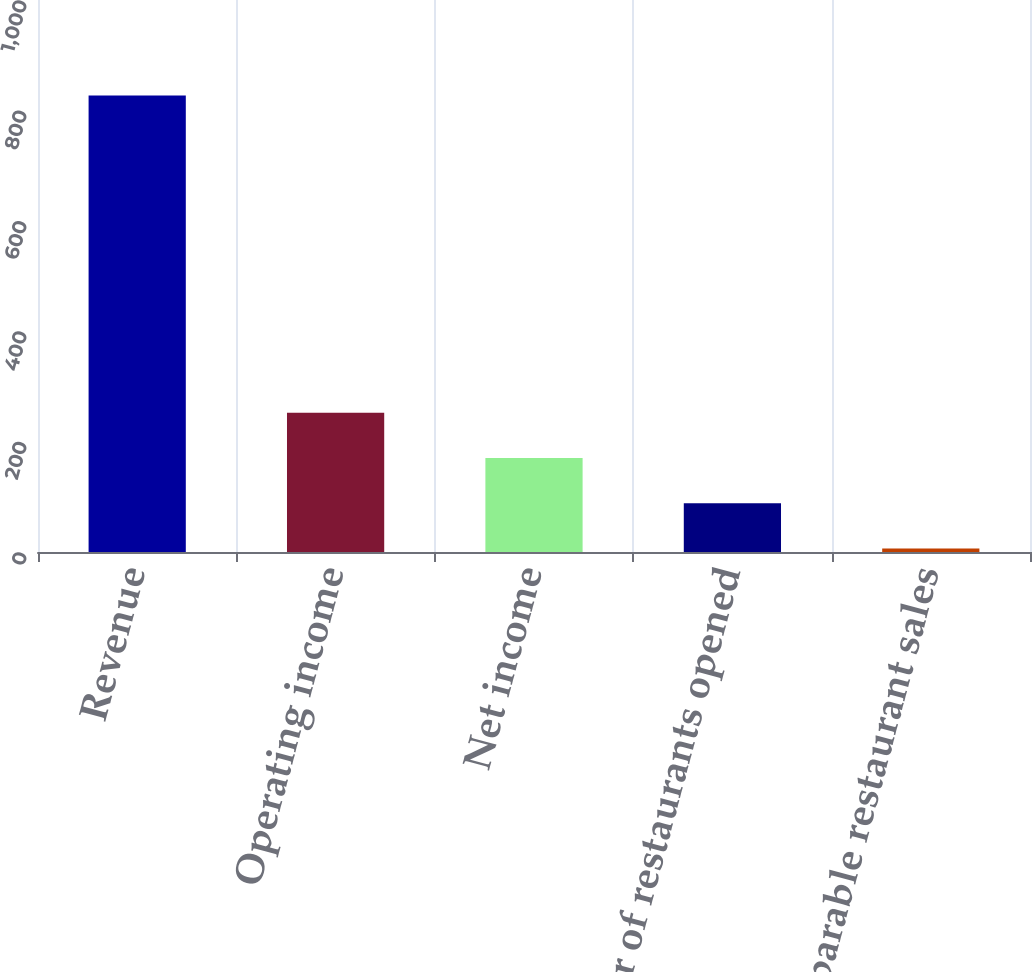Convert chart. <chart><loc_0><loc_0><loc_500><loc_500><bar_chart><fcel>Revenue<fcel>Operating income<fcel>Net income<fcel>Number of restaurants opened<fcel>Comparable restaurant sales<nl><fcel>826.9<fcel>252.41<fcel>170.34<fcel>88.27<fcel>6.2<nl></chart> 